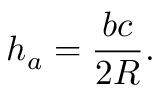<formula> <loc_0><loc_0><loc_500><loc_500>h _ { a } = { \frac { b c } { 2 R } } .</formula> 